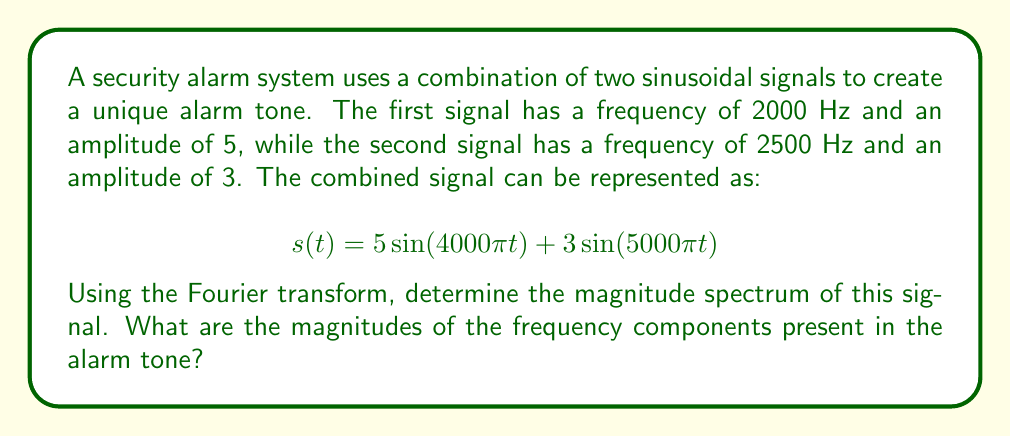Solve this math problem. To solve this problem, we need to apply the Fourier transform to the given signal and analyze its magnitude spectrum. Let's break it down step-by-step:

1) The Fourier transform of a sinusoidal signal $A\sin(2\pi ft)$ is given by:

   $$\mathcal{F}\{A\sin(2\pi ft)\} = \frac{A}{2}i[\delta(f_0 - f) - \delta(f_0 + f)]$$

   where $\delta$ is the Dirac delta function and $f_0$ is the frequency of the sinusoid.

2) For our signal $s(t) = 5\sin(4000\pi t) + 3\sin(5000\pi t)$, we have two components:
   
   a) $5\sin(4000\pi t)$ with $A_1 = 5$ and $f_1 = 2000$ Hz
   b) $3\sin(5000\pi t)$ with $A_2 = 3$ and $f_2 = 2500$ Hz

3) Applying the Fourier transform to each component:

   $$\mathcal{F}\{5\sin(4000\pi t)\} = \frac{5}{2}i[\delta(f - 2000) - \delta(f + 2000)]$$
   $$\mathcal{F}\{3\sin(5000\pi t)\} = \frac{3}{2}i[\delta(f - 2500) - \delta(f + 2500)]$$

4) The Fourier transform of the sum is the sum of the Fourier transforms:

   $$S(f) = \frac{5}{2}i[\delta(f - 2000) - \delta(f + 2000)] + \frac{3}{2}i[\delta(f - 2500) - \delta(f + 2500)]$$

5) The magnitude spectrum is given by the absolute value of $S(f)$:

   $$|S(f)| = \frac{5}{2}[\delta(f - 2000) + \delta(f + 2000)] + \frac{3}{2}[\delta(f - 2500) + \delta(f + 2500)]$$

6) This spectrum shows four impulses:
   - At $f = \pm 2000$ Hz with magnitude $\frac{5}{2} = 2.5$
   - At $f = \pm 2500$ Hz with magnitude $\frac{3}{2} = 1.5$

Therefore, the magnitude spectrum of the alarm signal consists of two frequency components:
- A component at 2000 Hz with magnitude 2.5
- A component at 2500 Hz with magnitude 1.5
Answer: The magnitude spectrum of the alarm signal consists of two frequency components:
1) At 2000 Hz with magnitude 2.5
2) At 2500 Hz with magnitude 1.5 